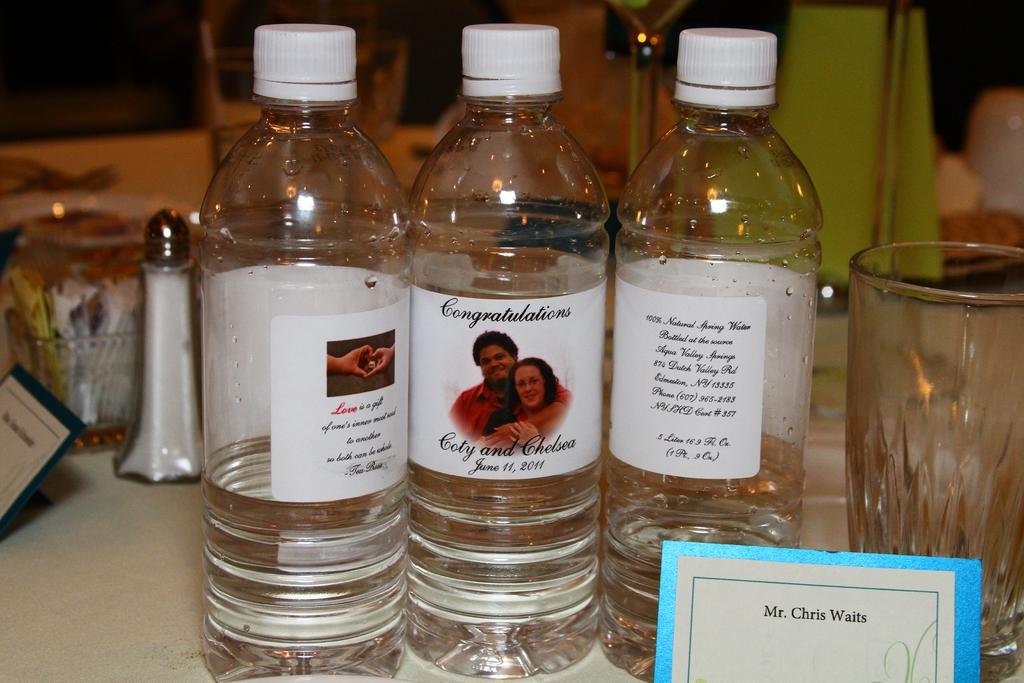How many bottles can be seen in the image? There are three bottles in the image. What else is present in the image besides the bottles? There is a paper with a name written on it and a glass in the image. What type of vegetable is growing out of the leg in the image? There is no leg or vegetable present in the image. 